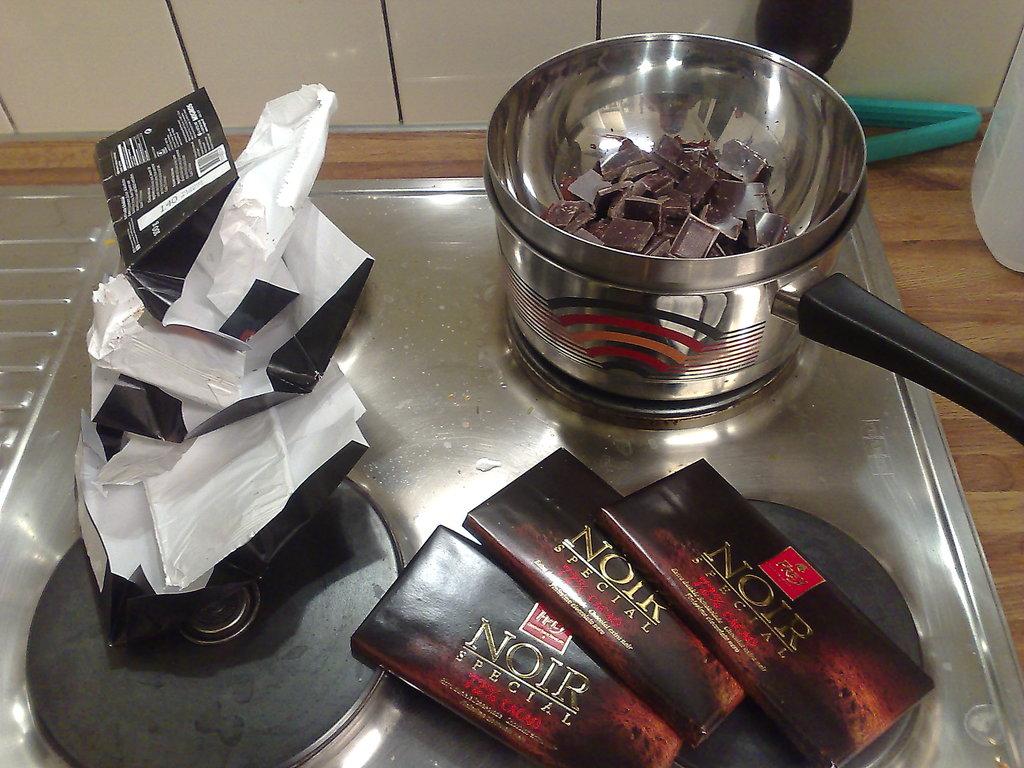What is being cooked ?
Make the answer very short. Chocolate. What is the text above special?
Your response must be concise. Noir. 